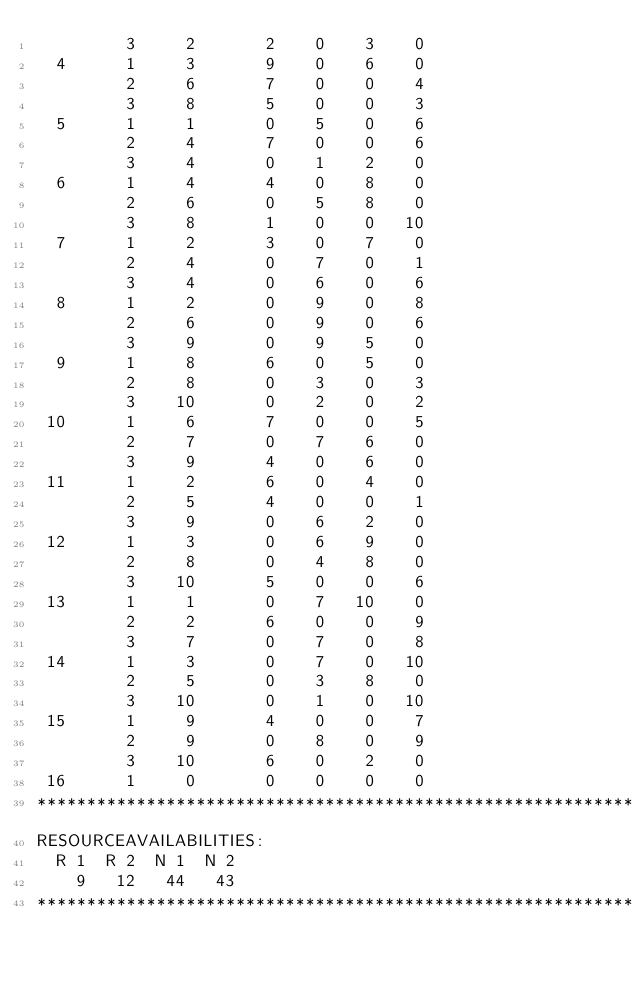Convert code to text. <code><loc_0><loc_0><loc_500><loc_500><_ObjectiveC_>         3     2       2    0    3    0
  4      1     3       9    0    6    0
         2     6       7    0    0    4
         3     8       5    0    0    3
  5      1     1       0    5    0    6
         2     4       7    0    0    6
         3     4       0    1    2    0
  6      1     4       4    0    8    0
         2     6       0    5    8    0
         3     8       1    0    0   10
  7      1     2       3    0    7    0
         2     4       0    7    0    1
         3     4       0    6    0    6
  8      1     2       0    9    0    8
         2     6       0    9    0    6
         3     9       0    9    5    0
  9      1     8       6    0    5    0
         2     8       0    3    0    3
         3    10       0    2    0    2
 10      1     6       7    0    0    5
         2     7       0    7    6    0
         3     9       4    0    6    0
 11      1     2       6    0    4    0
         2     5       4    0    0    1
         3     9       0    6    2    0
 12      1     3       0    6    9    0
         2     8       0    4    8    0
         3    10       5    0    0    6
 13      1     1       0    7   10    0
         2     2       6    0    0    9
         3     7       0    7    0    8
 14      1     3       0    7    0   10
         2     5       0    3    8    0
         3    10       0    1    0   10
 15      1     9       4    0    0    7
         2     9       0    8    0    9
         3    10       6    0    2    0
 16      1     0       0    0    0    0
************************************************************************
RESOURCEAVAILABILITIES:
  R 1  R 2  N 1  N 2
    9   12   44   43
************************************************************************
</code> 